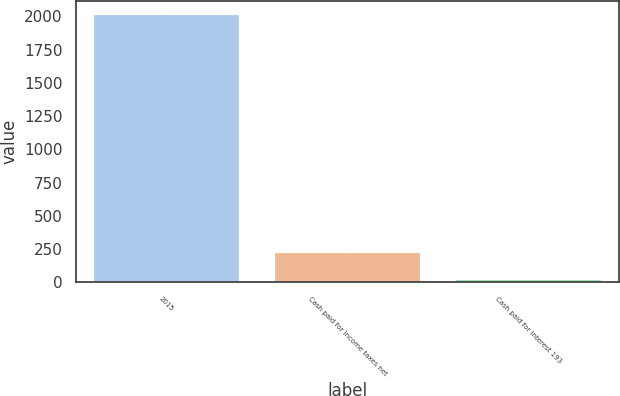Convert chart to OTSL. <chart><loc_0><loc_0><loc_500><loc_500><bar_chart><fcel>2015<fcel>Cash paid for income taxes net<fcel>Cash paid for interest 193<nl><fcel>2013<fcel>218.4<fcel>19<nl></chart> 